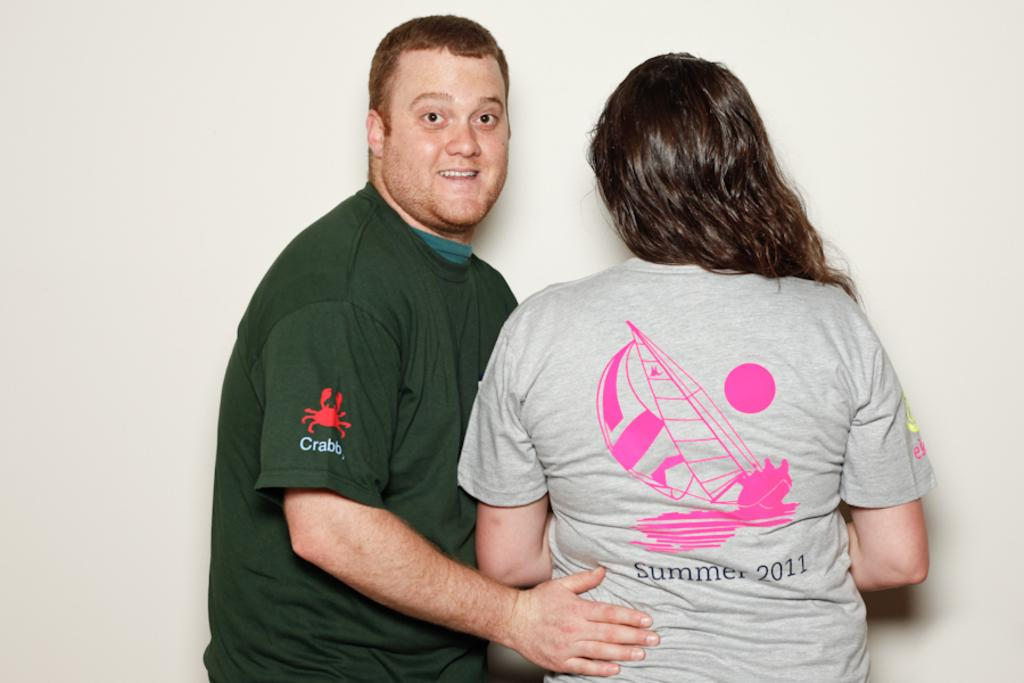Who is present in the image? There is a man and a woman in the image. What are the man and woman wearing? The man and woman are both wearing t-shirts. What is the man doing in the image? The man is putting his hand on the woman. What is the location of the man and woman in the image? Both the man and woman are standing near a wall. What type of feather can be seen in the image? There is no feather present in the image. Is the man holding a gun in the image? There is no gun present in the image. 